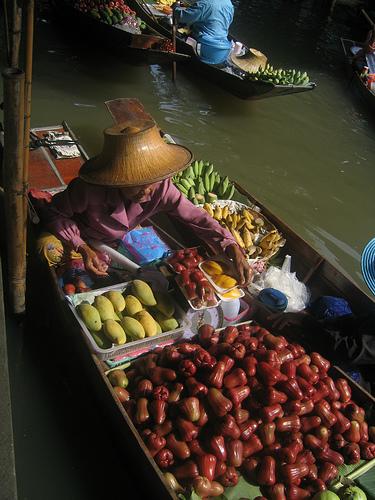What is on the man's head?
Give a very brief answer. Hat. What type of goods is this person surrounded by?
Short answer required. Fruit. What continent do you think this is?
Give a very brief answer. Asia. 